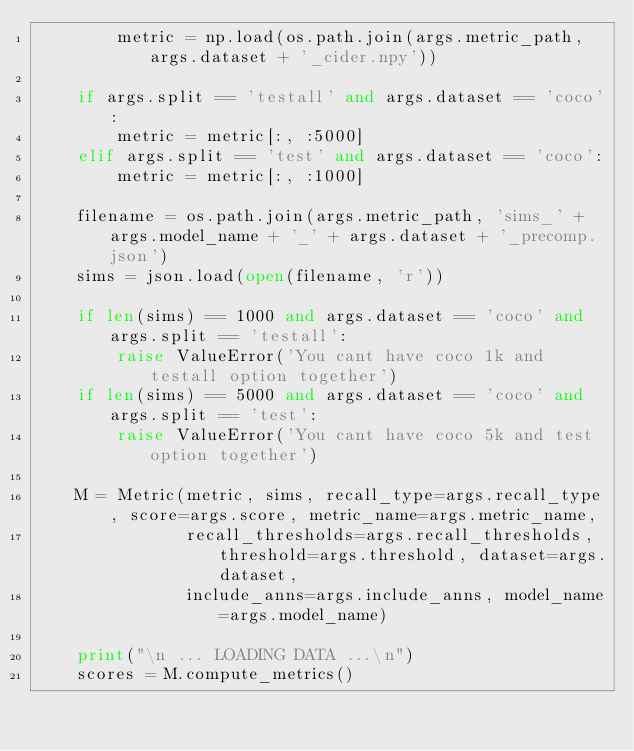Convert code to text. <code><loc_0><loc_0><loc_500><loc_500><_Python_>        metric = np.load(os.path.join(args.metric_path, args.dataset + '_cider.npy'))

    if args.split == 'testall' and args.dataset == 'coco':
        metric = metric[:, :5000]
    elif args.split == 'test' and args.dataset == 'coco':
        metric = metric[:, :1000]

    filename = os.path.join(args.metric_path, 'sims_' + args.model_name + '_' + args.dataset + '_precomp.json')
    sims = json.load(open(filename, 'r'))

    if len(sims) == 1000 and args.dataset == 'coco' and args.split == 'testall':
        raise ValueError('You cant have coco 1k and testall option together')
    if len(sims) == 5000 and args.dataset == 'coco' and args.split == 'test':
        raise ValueError('You cant have coco 5k and test option together')

    M = Metric(metric, sims, recall_type=args.recall_type, score=args.score, metric_name=args.metric_name,
               recall_thresholds=args.recall_thresholds, threshold=args.threshold, dataset=args.dataset,
               include_anns=args.include_anns, model_name=args.model_name)

    print("\n ... LOADING DATA ...\n")
    scores = M.compute_metrics()
</code> 